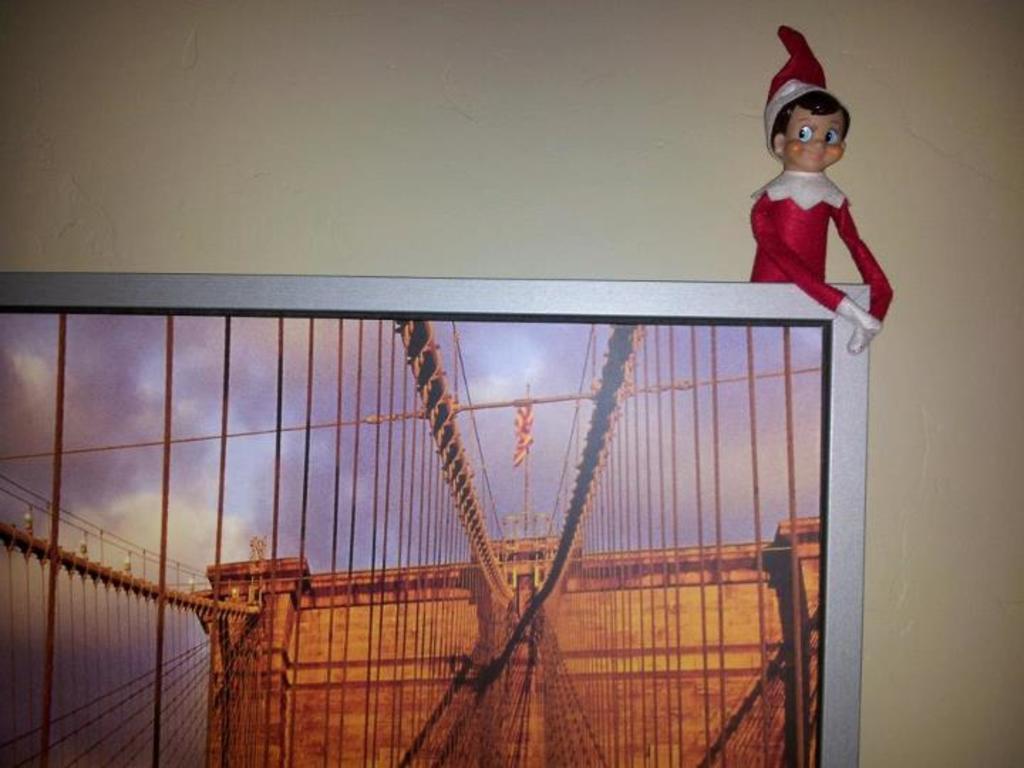Could you give a brief overview of what you see in this image? In this image I can see a screen on which I can see building , ropes, the sky and back side of screen I can see the wall and a doll visible in front of the wall. 